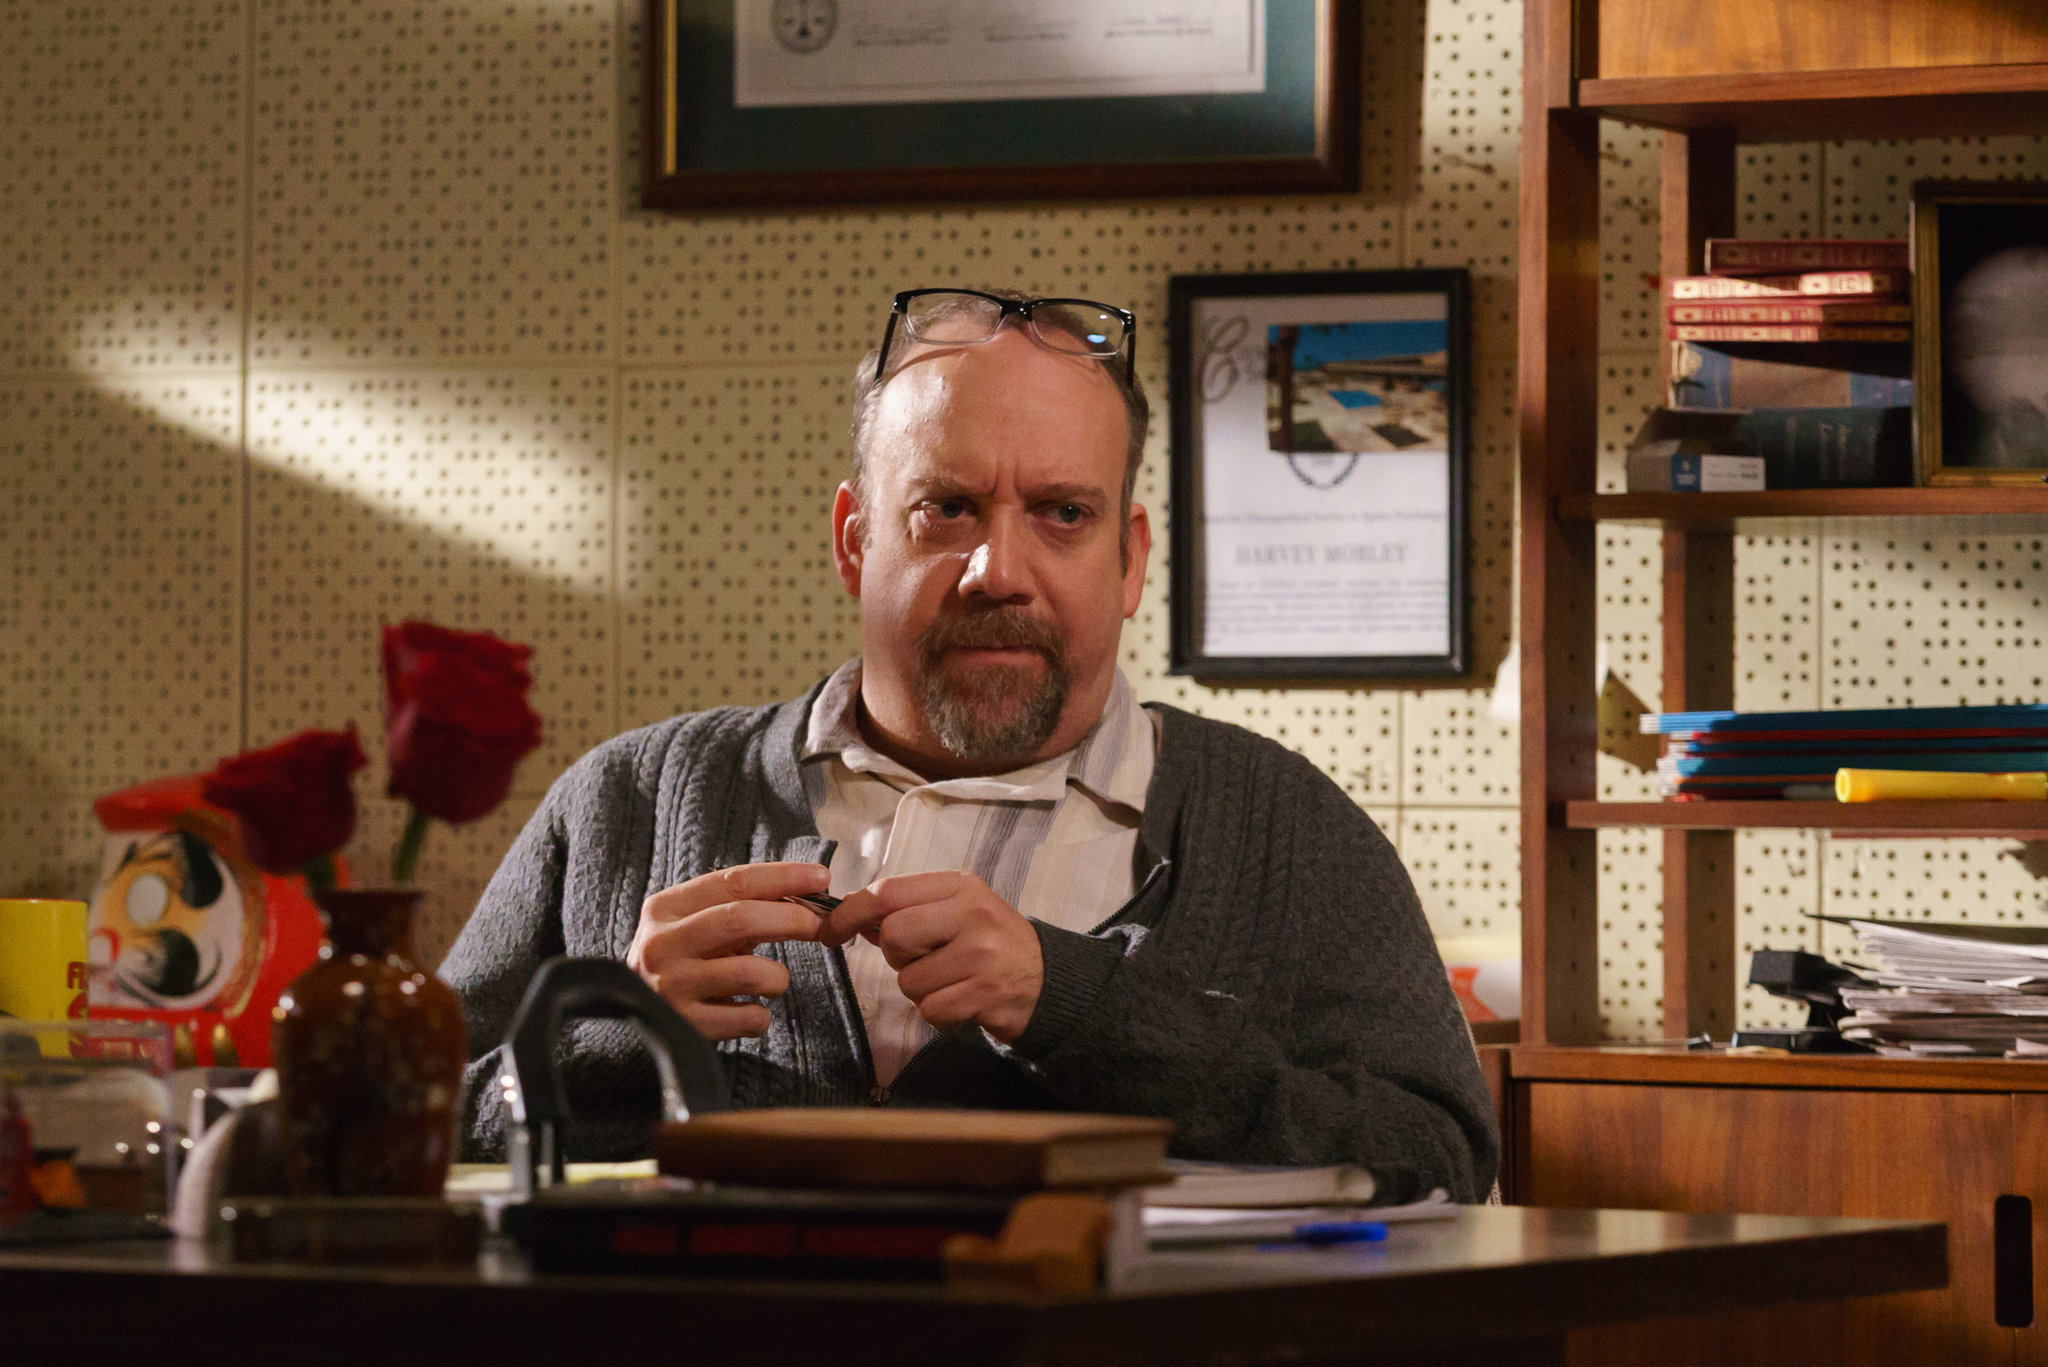Can you describe the artistic elements in the image that contribute to its overall mood? The artistic elements in the image play a significant role in creating a contemplative and intense mood. Firstly, the warm tones of brown and orange dominate the composition, imparting a cozy yet serious atmosphere. The lighting is subtle but effectively highlights the man's face, focusing the viewer's attention on his expression. The organized chaos of the desk, with books, papers, and a coffee mug, adds to the sense of busyness and intellectual engagement. The presence of personal items like the vase with red roses and colorful decorations blends the personal with the professional, suggesting a multifaceted character. The background, featuring a bookshelf and framed pictures or certificates, adds depth and context, reinforcing the intellectual environment. What might be the significance of the framed items and books in the background? The framed items and books in the background likely hold significant importance to the man in the image. The framed certificates or pictures may denote achievements, qualifications, or memorable moments that are meaningful to him, serving as inspirations or reminders of his journey. The bookshelf filled with books not only reflects his academic or professional interests but also suggests a commitment to continuous learning and knowledge accumulation. These elements together create a narrative that the man is dedicated, experienced, and values both his professional accomplishments and intellectual pursuits. 